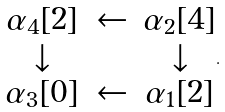<formula> <loc_0><loc_0><loc_500><loc_500>\begin{matrix} \alpha _ { 4 } [ 2 ] & \leftarrow & \alpha _ { 2 } [ 4 ] \\ \downarrow & & \downarrow \\ \alpha _ { 3 } [ 0 ] & \leftarrow & \alpha _ { 1 } [ 2 ] \end{matrix} .</formula> 